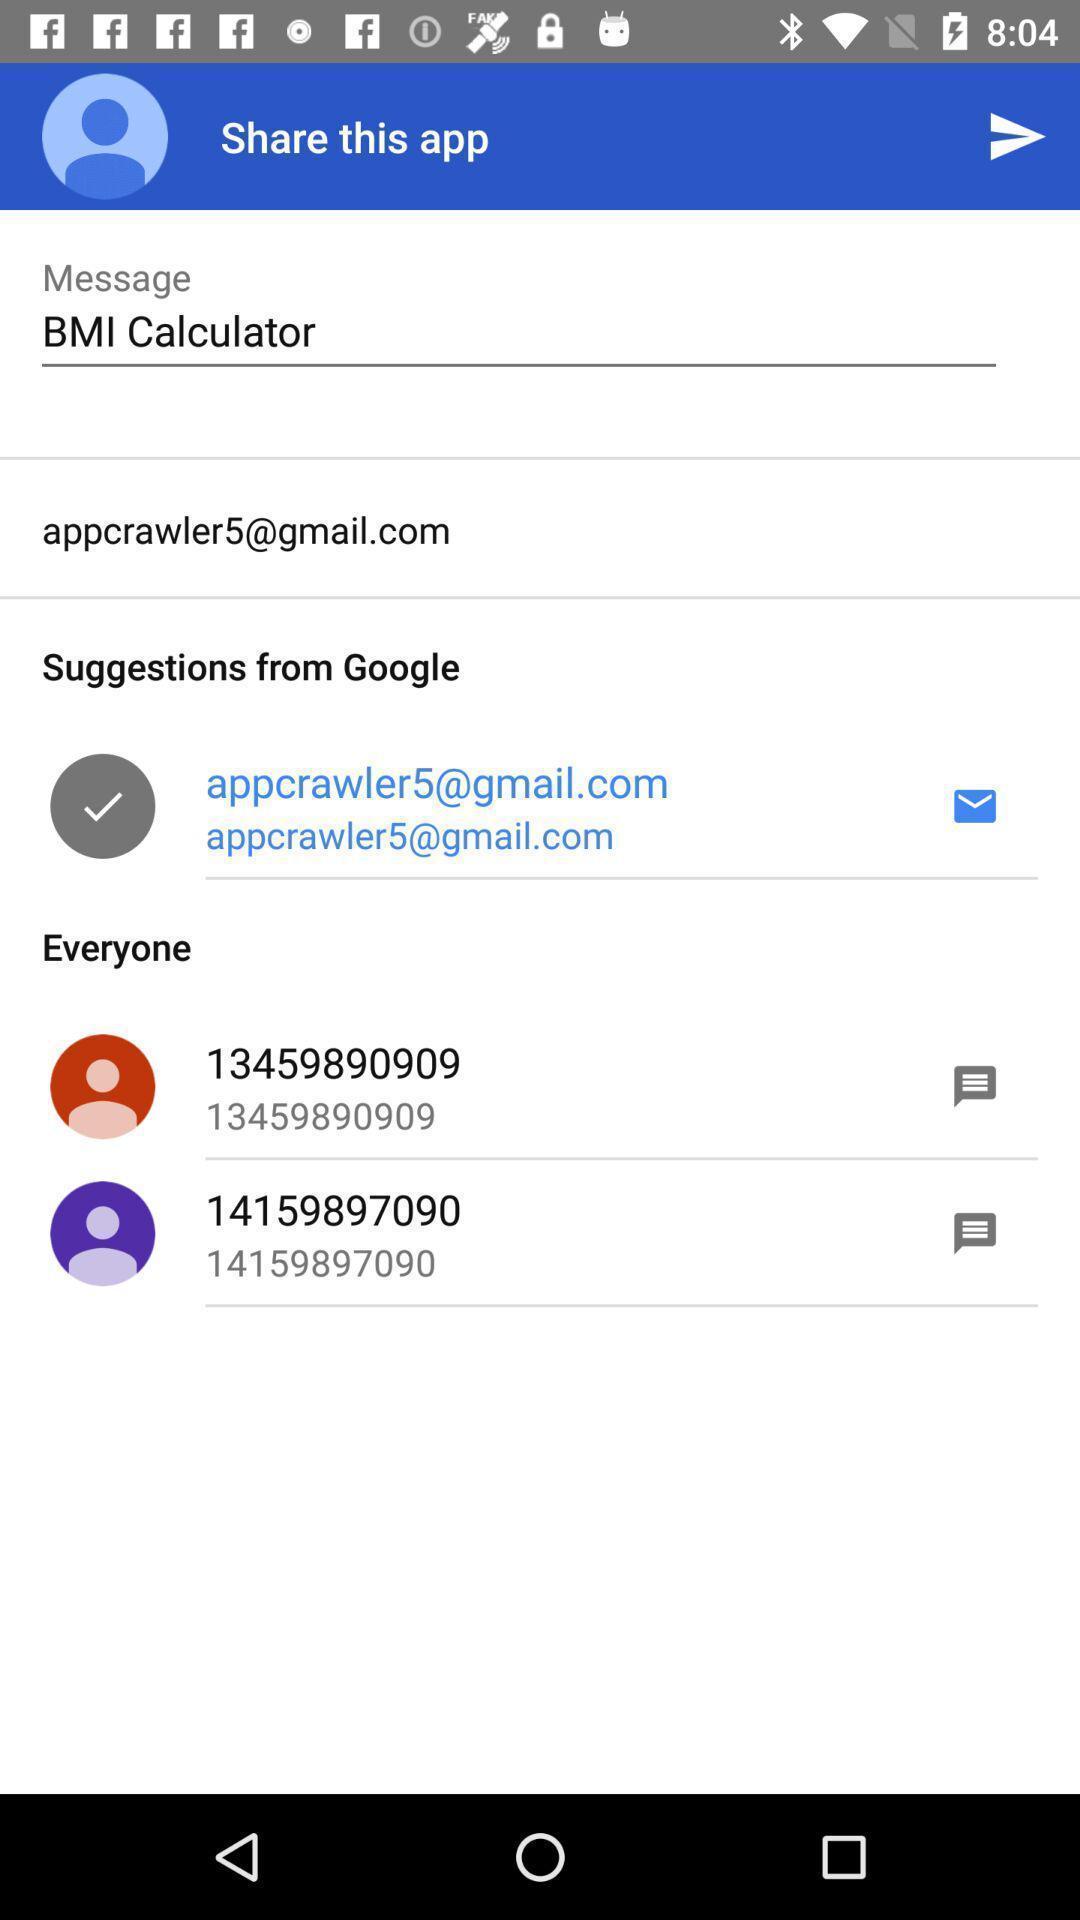Summarize the main components in this picture. Page to share application to contacts with message. 